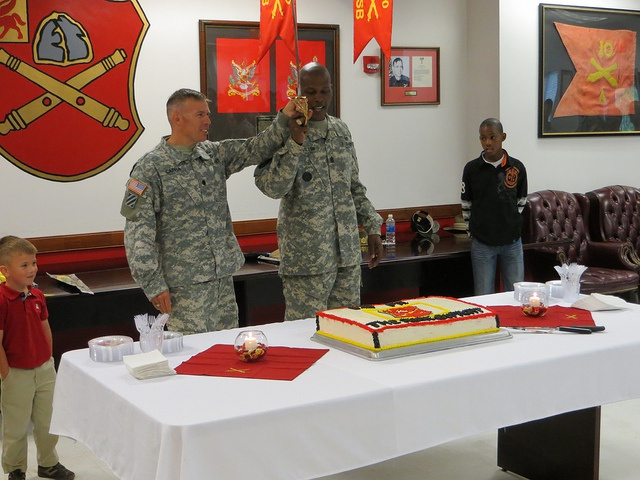Describe the objects in this image and their specific colors. I can see dining table in olive, lightgray, darkgray, black, and brown tones, people in olive, gray, and black tones, people in olive, gray, black, darkgreen, and maroon tones, people in olive, maroon, and gray tones, and people in olive, black, gray, maroon, and purple tones in this image. 